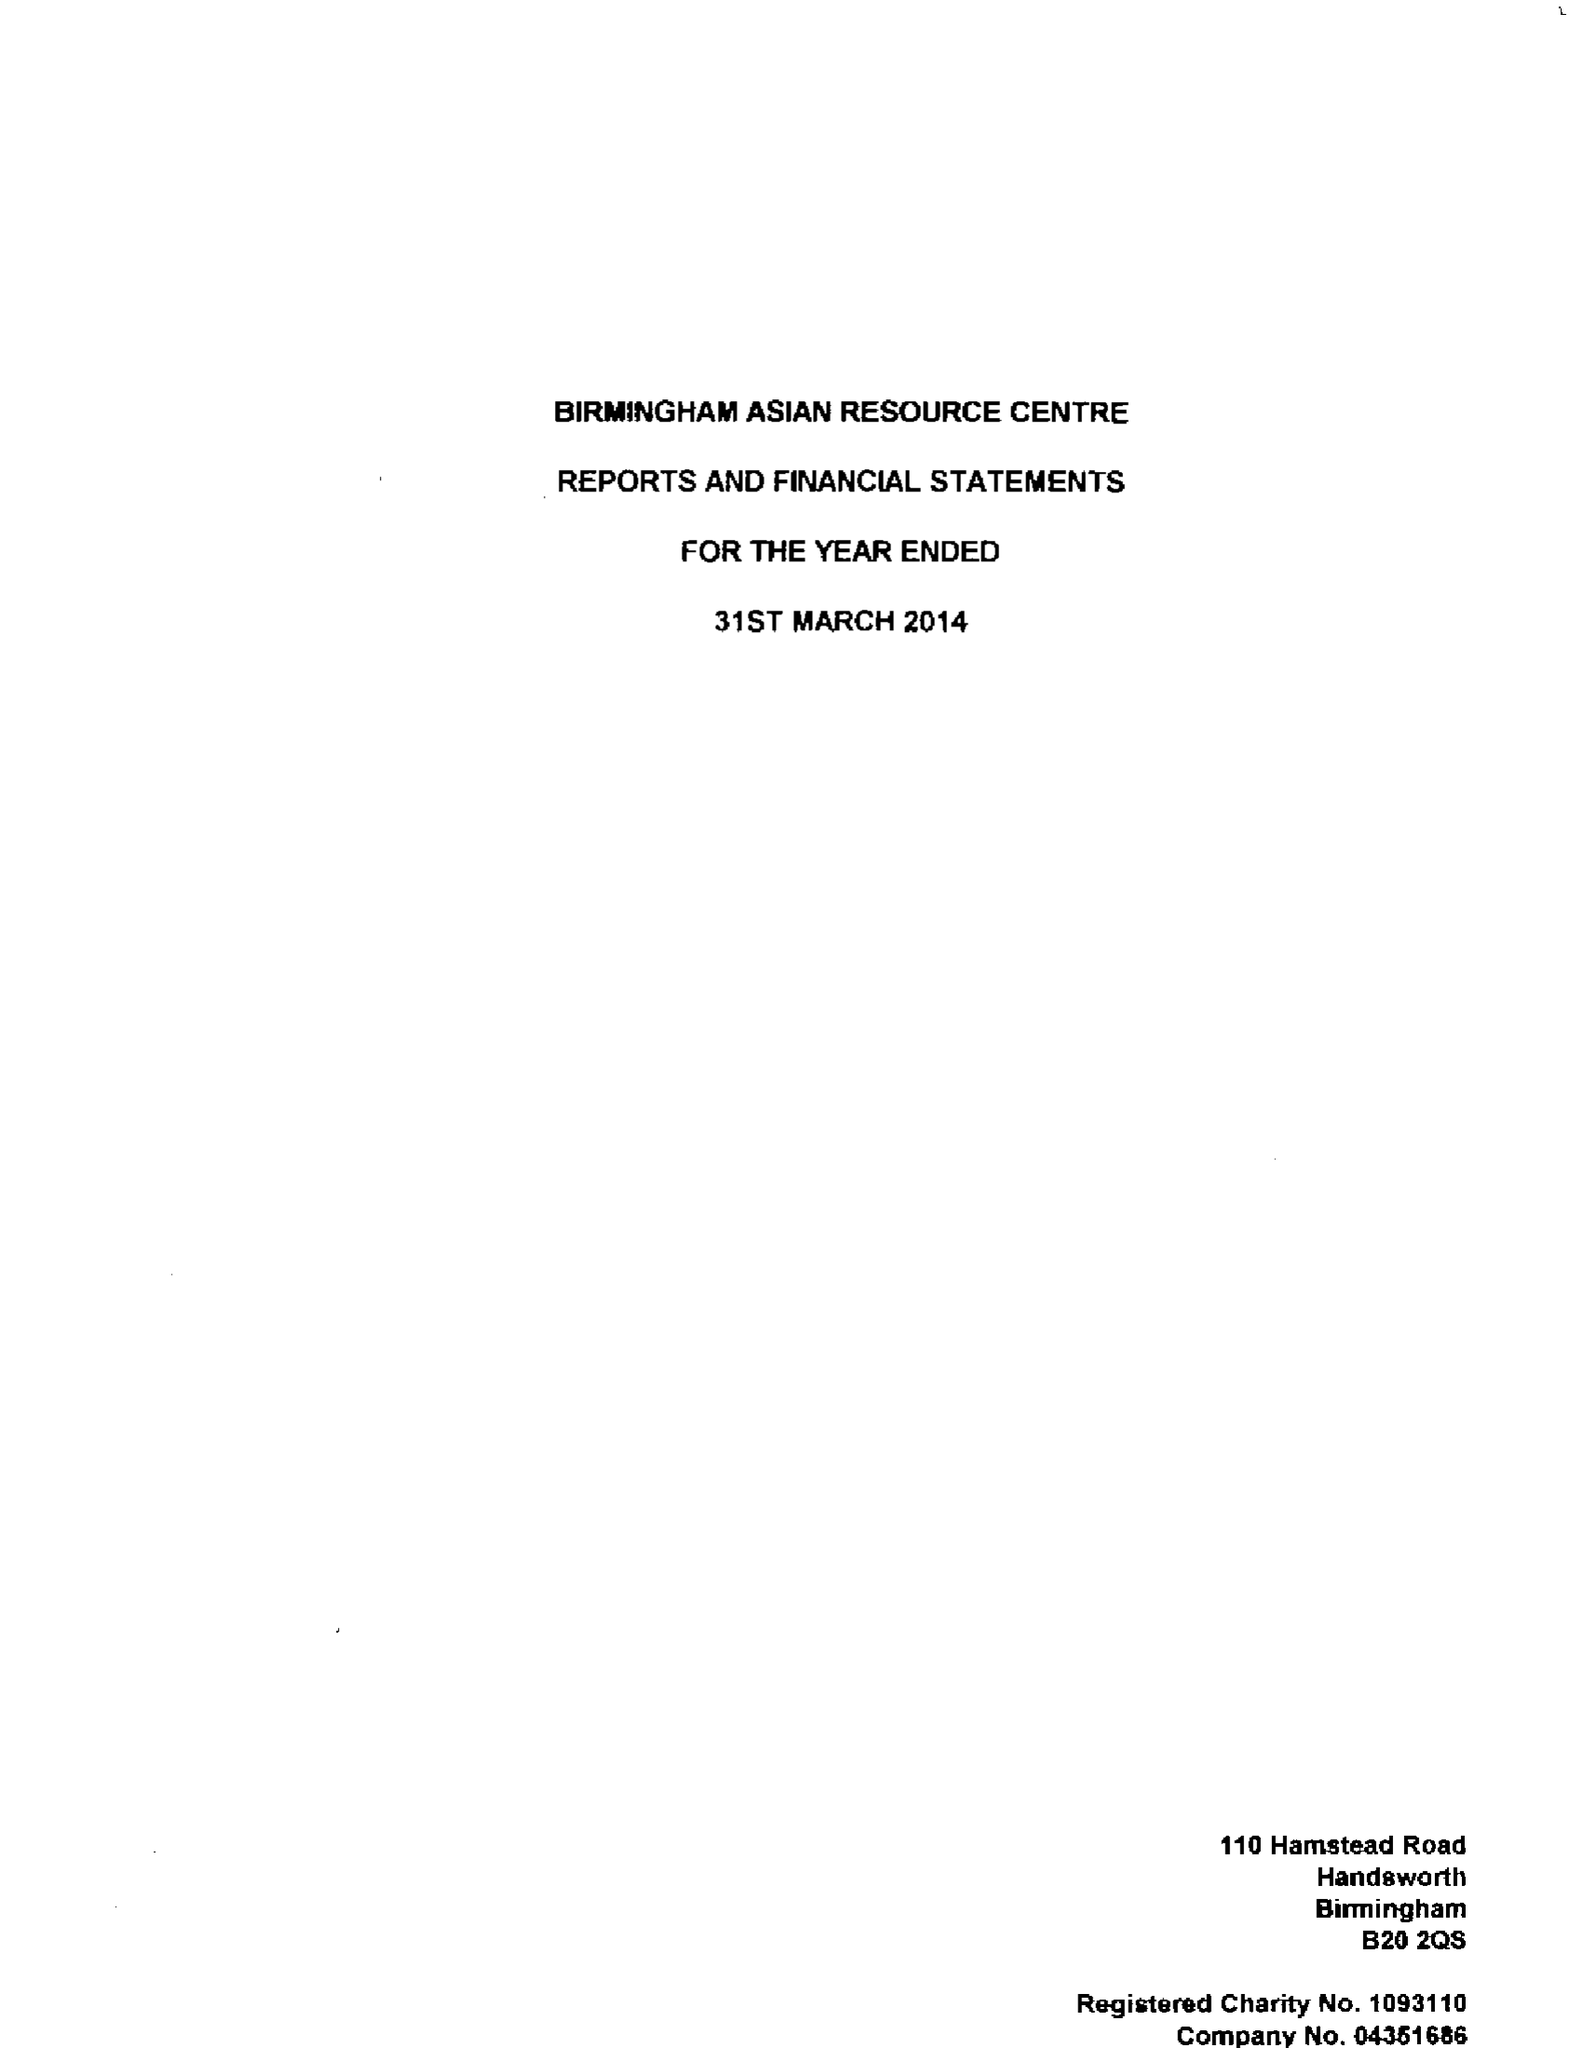What is the value for the income_annually_in_british_pounds?
Answer the question using a single word or phrase. 278250.00 